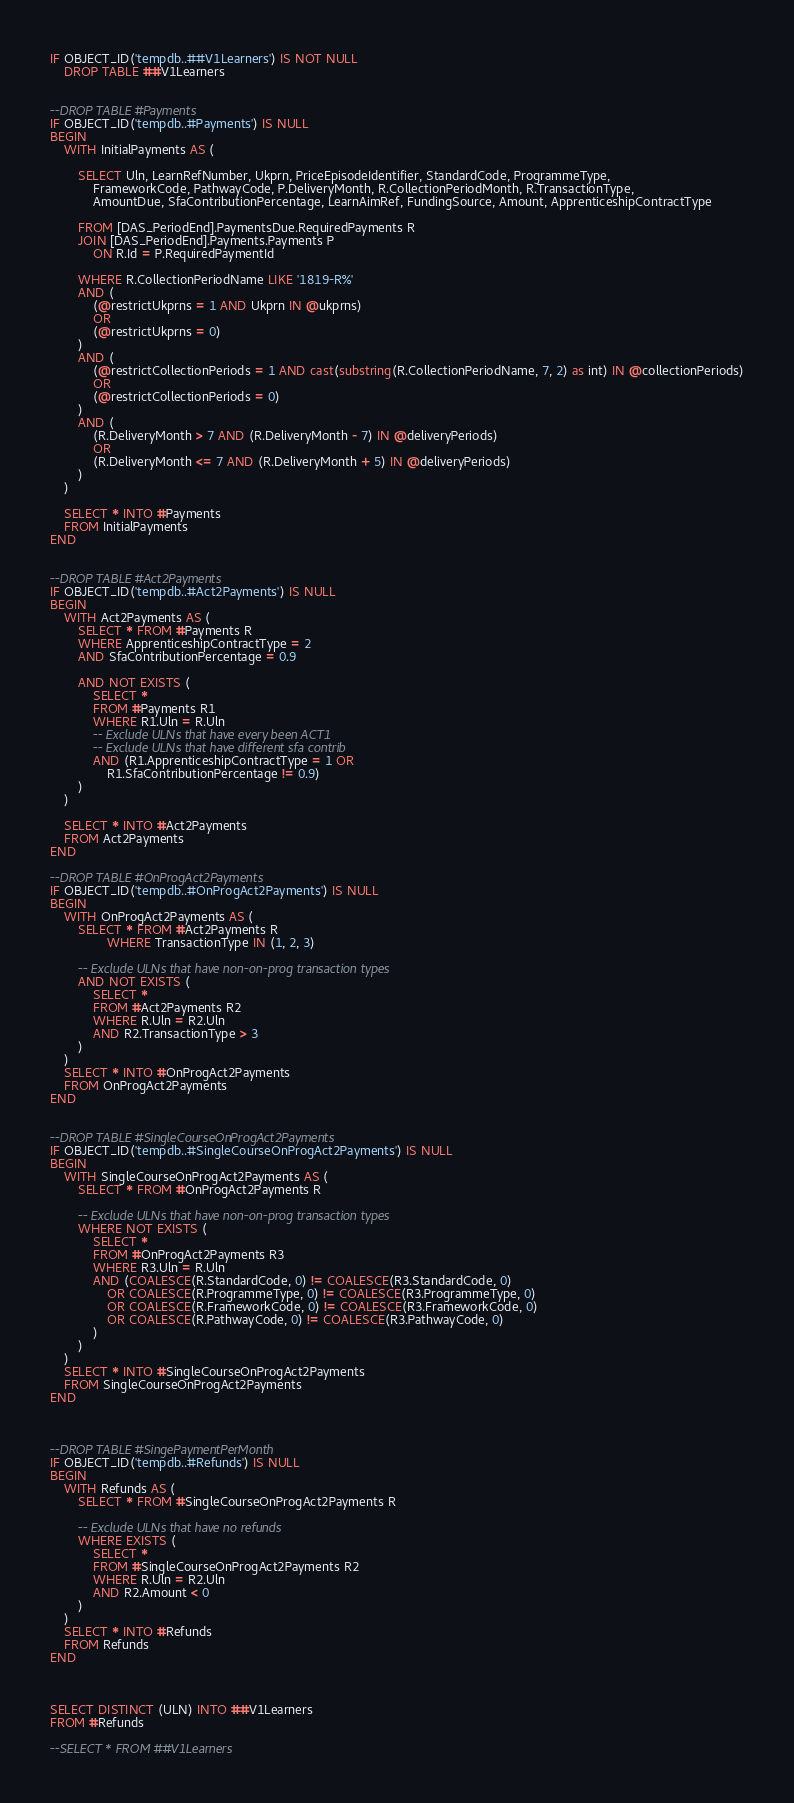<code> <loc_0><loc_0><loc_500><loc_500><_SQL_>

IF OBJECT_ID('tempdb..##V1Learners') IS NOT NULL
	DROP TABLE ##V1Learners


--DROP TABLE #Payments
IF OBJECT_ID('tempdb..#Payments') IS NULL 
BEGIN
	WITH InitialPayments AS (

		SELECT Uln, LearnRefNumber, Ukprn, PriceEpisodeIdentifier, StandardCode, ProgrammeType, 
			FrameworkCode, PathwayCode, P.DeliveryMonth, R.CollectionPeriodMonth, R.TransactionType,
			AmountDue, SfaContributionPercentage, LearnAimRef, FundingSource, Amount, ApprenticeshipContractType

		FROM [DAS_PeriodEnd].PaymentsDue.RequiredPayments R
		JOIN [DAS_PeriodEnd].Payments.Payments P
			ON R.Id = P.RequiredPaymentId

		WHERE R.CollectionPeriodName LIKE '1819-R%'
		AND (
			(@restrictUkprns = 1 AND Ukprn IN @ukprns)
			OR
			(@restrictUkprns = 0)
		)
		AND (
			(@restrictCollectionPeriods = 1 AND cast(substring(R.CollectionPeriodName, 7, 2) as int) IN @collectionPeriods)
			OR
			(@restrictCollectionPeriods = 0)
		)
		AND (
			(R.DeliveryMonth > 7 AND (R.DeliveryMonth - 7) IN @deliveryPeriods)
			OR
			(R.DeliveryMonth <= 7 AND (R.DeliveryMonth + 5) IN @deliveryPeriods)
		)
	)

	SELECT * INTO #Payments
	FROM InitialPayments
END


--DROP TABLE #Act2Payments
IF OBJECT_ID('tempdb..#Act2Payments') IS NULL 
BEGIN
	WITH Act2Payments AS (
		SELECT * FROM #Payments R
		WHERE ApprenticeshipContractType = 2
		AND SfaContributionPercentage = 0.9
		
		AND NOT EXISTS (
			SELECT * 
			FROM #Payments R1
			WHERE R1.Uln = R.Uln 
			-- Exclude ULNs that have every been ACT1
			-- Exclude ULNs that have different sfa contrib 
			AND (R1.ApprenticeshipContractType = 1 OR
				R1.SfaContributionPercentage != 0.9)
		)
	)

	SELECT * INTO #Act2Payments 
	FROM Act2Payments
END

--DROP TABLE #OnProgAct2Payments
IF OBJECT_ID('tempdb..#OnProgAct2Payments') IS NULL 
BEGIN
	WITH OnProgAct2Payments AS (
		SELECT * FROM #Act2Payments R
				WHERE TransactionType IN (1, 2, 3)

		-- Exclude ULNs that have non-on-prog transaction types
		AND NOT EXISTS (
			SELECT *
			FROM #Act2Payments R2
			WHERE R.Uln = R2.Uln
			AND R2.TransactionType > 3
		)
	)
	SELECT * INTO #OnProgAct2Payments
	FROM OnProgAct2Payments
END


--DROP TABLE #SingleCourseOnProgAct2Payments
IF OBJECT_ID('tempdb..#SingleCourseOnProgAct2Payments') IS NULL 
BEGIN
	WITH SingleCourseOnProgAct2Payments AS (
		SELECT * FROM #OnProgAct2Payments R

		-- Exclude ULNs that have non-on-prog transaction types
		WHERE NOT EXISTS (
			SELECT *
			FROM #OnProgAct2Payments R3
			WHERE R3.Uln = R.Uln
			AND (COALESCE(R.StandardCode, 0) != COALESCE(R3.StandardCode, 0)
				OR COALESCE(R.ProgrammeType, 0) != COALESCE(R3.ProgrammeType, 0)
				OR COALESCE(R.FrameworkCode, 0) != COALESCE(R3.FrameworkCode, 0)
				OR COALESCE(R.PathwayCode, 0) != COALESCE(R3.PathwayCode, 0)
			)
		)
	)
	SELECT * INTO #SingleCourseOnProgAct2Payments
	FROM SingleCourseOnProgAct2Payments
END



--DROP TABLE #SingePaymentPerMonth
IF OBJECT_ID('tempdb..#Refunds') IS NULL 
BEGIN
	WITH Refunds AS (
		SELECT * FROM #SingleCourseOnProgAct2Payments R

		-- Exclude ULNs that have no refunds
		WHERE EXISTS (
			SELECT *
			FROM #SingleCourseOnProgAct2Payments R2
			WHERE R.Uln = R2.Uln
			AND R2.Amount < 0
		)
	)
	SELECT * INTO #Refunds
	FROM Refunds
END



SELECT DISTINCT (ULN) INTO ##V1Learners
FROM #Refunds

--SELECT * FROM ##V1Learners
</code> 